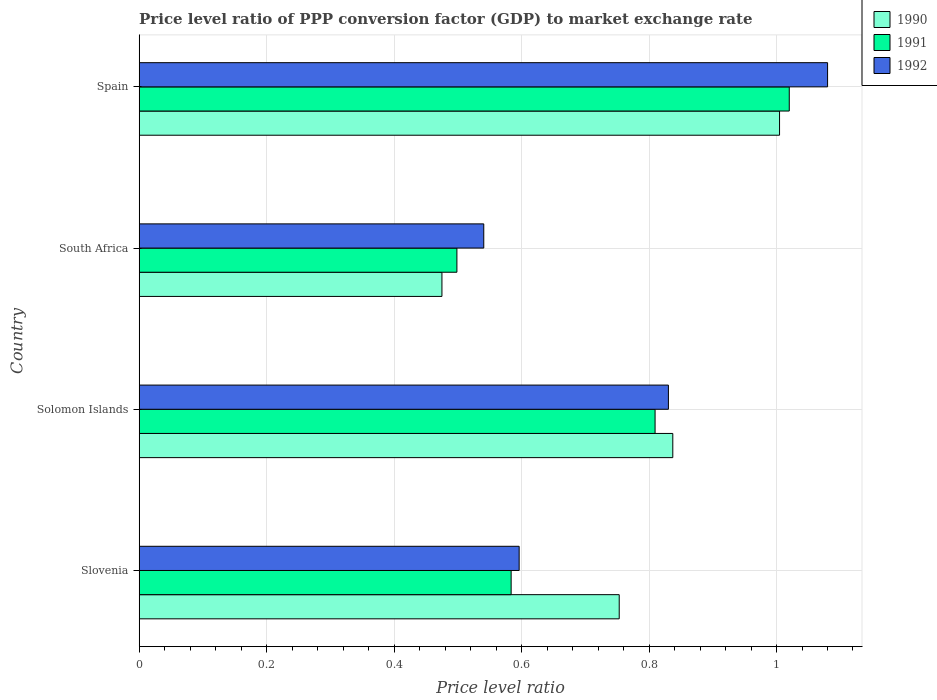How many groups of bars are there?
Provide a short and direct response. 4. Are the number of bars per tick equal to the number of legend labels?
Ensure brevity in your answer.  Yes. Are the number of bars on each tick of the Y-axis equal?
Make the answer very short. Yes. What is the label of the 2nd group of bars from the top?
Provide a short and direct response. South Africa. In how many cases, is the number of bars for a given country not equal to the number of legend labels?
Your answer should be very brief. 0. What is the price level ratio in 1992 in Solomon Islands?
Make the answer very short. 0.83. Across all countries, what is the maximum price level ratio in 1992?
Keep it short and to the point. 1.08. Across all countries, what is the minimum price level ratio in 1991?
Give a very brief answer. 0.5. In which country was the price level ratio in 1991 maximum?
Keep it short and to the point. Spain. In which country was the price level ratio in 1992 minimum?
Provide a succinct answer. South Africa. What is the total price level ratio in 1992 in the graph?
Make the answer very short. 3.05. What is the difference between the price level ratio in 1991 in Slovenia and that in Solomon Islands?
Ensure brevity in your answer.  -0.23. What is the difference between the price level ratio in 1992 in Spain and the price level ratio in 1990 in Slovenia?
Make the answer very short. 0.33. What is the average price level ratio in 1991 per country?
Give a very brief answer. 0.73. What is the difference between the price level ratio in 1992 and price level ratio in 1990 in Slovenia?
Make the answer very short. -0.16. In how many countries, is the price level ratio in 1991 greater than 0.7600000000000001 ?
Your answer should be compact. 2. What is the ratio of the price level ratio in 1991 in Solomon Islands to that in South Africa?
Offer a very short reply. 1.62. Is the price level ratio in 1990 in Solomon Islands less than that in South Africa?
Your answer should be very brief. No. What is the difference between the highest and the second highest price level ratio in 1990?
Your response must be concise. 0.17. What is the difference between the highest and the lowest price level ratio in 1990?
Provide a succinct answer. 0.53. In how many countries, is the price level ratio in 1992 greater than the average price level ratio in 1992 taken over all countries?
Your answer should be compact. 2. Is it the case that in every country, the sum of the price level ratio in 1992 and price level ratio in 1991 is greater than the price level ratio in 1990?
Offer a very short reply. Yes. How many countries are there in the graph?
Your response must be concise. 4. Does the graph contain any zero values?
Offer a very short reply. No. How many legend labels are there?
Provide a short and direct response. 3. How are the legend labels stacked?
Make the answer very short. Vertical. What is the title of the graph?
Keep it short and to the point. Price level ratio of PPP conversion factor (GDP) to market exchange rate. Does "1982" appear as one of the legend labels in the graph?
Provide a short and direct response. No. What is the label or title of the X-axis?
Make the answer very short. Price level ratio. What is the label or title of the Y-axis?
Offer a very short reply. Country. What is the Price level ratio in 1990 in Slovenia?
Provide a short and direct response. 0.75. What is the Price level ratio in 1991 in Slovenia?
Provide a short and direct response. 0.58. What is the Price level ratio in 1992 in Slovenia?
Offer a very short reply. 0.6. What is the Price level ratio of 1990 in Solomon Islands?
Ensure brevity in your answer.  0.84. What is the Price level ratio of 1991 in Solomon Islands?
Your answer should be very brief. 0.81. What is the Price level ratio of 1992 in Solomon Islands?
Offer a terse response. 0.83. What is the Price level ratio in 1990 in South Africa?
Your answer should be very brief. 0.48. What is the Price level ratio in 1991 in South Africa?
Your answer should be compact. 0.5. What is the Price level ratio in 1992 in South Africa?
Provide a short and direct response. 0.54. What is the Price level ratio in 1990 in Spain?
Provide a short and direct response. 1. What is the Price level ratio of 1991 in Spain?
Keep it short and to the point. 1.02. What is the Price level ratio of 1992 in Spain?
Provide a short and direct response. 1.08. Across all countries, what is the maximum Price level ratio in 1990?
Give a very brief answer. 1. Across all countries, what is the maximum Price level ratio of 1991?
Keep it short and to the point. 1.02. Across all countries, what is the maximum Price level ratio in 1992?
Your response must be concise. 1.08. Across all countries, what is the minimum Price level ratio of 1990?
Your response must be concise. 0.48. Across all countries, what is the minimum Price level ratio of 1991?
Your answer should be very brief. 0.5. Across all countries, what is the minimum Price level ratio in 1992?
Provide a short and direct response. 0.54. What is the total Price level ratio of 1990 in the graph?
Your response must be concise. 3.07. What is the total Price level ratio of 1991 in the graph?
Offer a very short reply. 2.91. What is the total Price level ratio in 1992 in the graph?
Offer a terse response. 3.05. What is the difference between the Price level ratio in 1990 in Slovenia and that in Solomon Islands?
Keep it short and to the point. -0.08. What is the difference between the Price level ratio of 1991 in Slovenia and that in Solomon Islands?
Your answer should be compact. -0.23. What is the difference between the Price level ratio of 1992 in Slovenia and that in Solomon Islands?
Ensure brevity in your answer.  -0.23. What is the difference between the Price level ratio of 1990 in Slovenia and that in South Africa?
Make the answer very short. 0.28. What is the difference between the Price level ratio of 1991 in Slovenia and that in South Africa?
Provide a succinct answer. 0.09. What is the difference between the Price level ratio of 1992 in Slovenia and that in South Africa?
Your answer should be very brief. 0.06. What is the difference between the Price level ratio in 1990 in Slovenia and that in Spain?
Your answer should be very brief. -0.25. What is the difference between the Price level ratio in 1991 in Slovenia and that in Spain?
Your answer should be compact. -0.44. What is the difference between the Price level ratio of 1992 in Slovenia and that in Spain?
Your answer should be compact. -0.48. What is the difference between the Price level ratio of 1990 in Solomon Islands and that in South Africa?
Provide a succinct answer. 0.36. What is the difference between the Price level ratio in 1991 in Solomon Islands and that in South Africa?
Keep it short and to the point. 0.31. What is the difference between the Price level ratio in 1992 in Solomon Islands and that in South Africa?
Offer a terse response. 0.29. What is the difference between the Price level ratio in 1990 in Solomon Islands and that in Spain?
Your response must be concise. -0.17. What is the difference between the Price level ratio of 1991 in Solomon Islands and that in Spain?
Provide a succinct answer. -0.21. What is the difference between the Price level ratio of 1992 in Solomon Islands and that in Spain?
Make the answer very short. -0.25. What is the difference between the Price level ratio of 1990 in South Africa and that in Spain?
Your response must be concise. -0.53. What is the difference between the Price level ratio of 1991 in South Africa and that in Spain?
Your answer should be very brief. -0.52. What is the difference between the Price level ratio in 1992 in South Africa and that in Spain?
Provide a short and direct response. -0.54. What is the difference between the Price level ratio in 1990 in Slovenia and the Price level ratio in 1991 in Solomon Islands?
Offer a terse response. -0.06. What is the difference between the Price level ratio of 1990 in Slovenia and the Price level ratio of 1992 in Solomon Islands?
Your answer should be very brief. -0.08. What is the difference between the Price level ratio in 1991 in Slovenia and the Price level ratio in 1992 in Solomon Islands?
Provide a succinct answer. -0.25. What is the difference between the Price level ratio in 1990 in Slovenia and the Price level ratio in 1991 in South Africa?
Keep it short and to the point. 0.25. What is the difference between the Price level ratio of 1990 in Slovenia and the Price level ratio of 1992 in South Africa?
Offer a terse response. 0.21. What is the difference between the Price level ratio of 1991 in Slovenia and the Price level ratio of 1992 in South Africa?
Ensure brevity in your answer.  0.04. What is the difference between the Price level ratio of 1990 in Slovenia and the Price level ratio of 1991 in Spain?
Provide a succinct answer. -0.27. What is the difference between the Price level ratio of 1990 in Slovenia and the Price level ratio of 1992 in Spain?
Give a very brief answer. -0.33. What is the difference between the Price level ratio in 1991 in Slovenia and the Price level ratio in 1992 in Spain?
Make the answer very short. -0.5. What is the difference between the Price level ratio of 1990 in Solomon Islands and the Price level ratio of 1991 in South Africa?
Your answer should be very brief. 0.34. What is the difference between the Price level ratio of 1990 in Solomon Islands and the Price level ratio of 1992 in South Africa?
Your answer should be compact. 0.3. What is the difference between the Price level ratio in 1991 in Solomon Islands and the Price level ratio in 1992 in South Africa?
Keep it short and to the point. 0.27. What is the difference between the Price level ratio of 1990 in Solomon Islands and the Price level ratio of 1991 in Spain?
Provide a short and direct response. -0.18. What is the difference between the Price level ratio of 1990 in Solomon Islands and the Price level ratio of 1992 in Spain?
Your response must be concise. -0.24. What is the difference between the Price level ratio of 1991 in Solomon Islands and the Price level ratio of 1992 in Spain?
Provide a succinct answer. -0.27. What is the difference between the Price level ratio in 1990 in South Africa and the Price level ratio in 1991 in Spain?
Keep it short and to the point. -0.55. What is the difference between the Price level ratio in 1990 in South Africa and the Price level ratio in 1992 in Spain?
Give a very brief answer. -0.61. What is the difference between the Price level ratio in 1991 in South Africa and the Price level ratio in 1992 in Spain?
Offer a terse response. -0.58. What is the average Price level ratio in 1990 per country?
Offer a very short reply. 0.77. What is the average Price level ratio of 1991 per country?
Your response must be concise. 0.73. What is the average Price level ratio of 1992 per country?
Your answer should be very brief. 0.76. What is the difference between the Price level ratio of 1990 and Price level ratio of 1991 in Slovenia?
Make the answer very short. 0.17. What is the difference between the Price level ratio of 1990 and Price level ratio of 1992 in Slovenia?
Provide a succinct answer. 0.16. What is the difference between the Price level ratio in 1991 and Price level ratio in 1992 in Slovenia?
Keep it short and to the point. -0.01. What is the difference between the Price level ratio in 1990 and Price level ratio in 1991 in Solomon Islands?
Provide a short and direct response. 0.03. What is the difference between the Price level ratio in 1990 and Price level ratio in 1992 in Solomon Islands?
Your response must be concise. 0.01. What is the difference between the Price level ratio in 1991 and Price level ratio in 1992 in Solomon Islands?
Offer a very short reply. -0.02. What is the difference between the Price level ratio of 1990 and Price level ratio of 1991 in South Africa?
Provide a succinct answer. -0.02. What is the difference between the Price level ratio in 1990 and Price level ratio in 1992 in South Africa?
Keep it short and to the point. -0.07. What is the difference between the Price level ratio in 1991 and Price level ratio in 1992 in South Africa?
Provide a succinct answer. -0.04. What is the difference between the Price level ratio of 1990 and Price level ratio of 1991 in Spain?
Your answer should be compact. -0.02. What is the difference between the Price level ratio in 1990 and Price level ratio in 1992 in Spain?
Keep it short and to the point. -0.08. What is the difference between the Price level ratio of 1991 and Price level ratio of 1992 in Spain?
Keep it short and to the point. -0.06. What is the ratio of the Price level ratio in 1990 in Slovenia to that in Solomon Islands?
Keep it short and to the point. 0.9. What is the ratio of the Price level ratio of 1991 in Slovenia to that in Solomon Islands?
Give a very brief answer. 0.72. What is the ratio of the Price level ratio in 1992 in Slovenia to that in Solomon Islands?
Provide a short and direct response. 0.72. What is the ratio of the Price level ratio in 1990 in Slovenia to that in South Africa?
Provide a succinct answer. 1.59. What is the ratio of the Price level ratio of 1991 in Slovenia to that in South Africa?
Your answer should be compact. 1.17. What is the ratio of the Price level ratio of 1992 in Slovenia to that in South Africa?
Keep it short and to the point. 1.1. What is the ratio of the Price level ratio of 1990 in Slovenia to that in Spain?
Offer a very short reply. 0.75. What is the ratio of the Price level ratio in 1991 in Slovenia to that in Spain?
Make the answer very short. 0.57. What is the ratio of the Price level ratio in 1992 in Slovenia to that in Spain?
Provide a short and direct response. 0.55. What is the ratio of the Price level ratio of 1990 in Solomon Islands to that in South Africa?
Your answer should be compact. 1.76. What is the ratio of the Price level ratio in 1991 in Solomon Islands to that in South Africa?
Your answer should be compact. 1.62. What is the ratio of the Price level ratio of 1992 in Solomon Islands to that in South Africa?
Offer a very short reply. 1.54. What is the ratio of the Price level ratio of 1990 in Solomon Islands to that in Spain?
Provide a succinct answer. 0.83. What is the ratio of the Price level ratio in 1991 in Solomon Islands to that in Spain?
Make the answer very short. 0.79. What is the ratio of the Price level ratio in 1992 in Solomon Islands to that in Spain?
Offer a terse response. 0.77. What is the ratio of the Price level ratio in 1990 in South Africa to that in Spain?
Your answer should be compact. 0.47. What is the ratio of the Price level ratio of 1991 in South Africa to that in Spain?
Offer a very short reply. 0.49. What is the ratio of the Price level ratio of 1992 in South Africa to that in Spain?
Make the answer very short. 0.5. What is the difference between the highest and the second highest Price level ratio of 1990?
Your answer should be compact. 0.17. What is the difference between the highest and the second highest Price level ratio in 1991?
Make the answer very short. 0.21. What is the difference between the highest and the second highest Price level ratio in 1992?
Your response must be concise. 0.25. What is the difference between the highest and the lowest Price level ratio of 1990?
Give a very brief answer. 0.53. What is the difference between the highest and the lowest Price level ratio of 1991?
Offer a very short reply. 0.52. What is the difference between the highest and the lowest Price level ratio in 1992?
Provide a succinct answer. 0.54. 